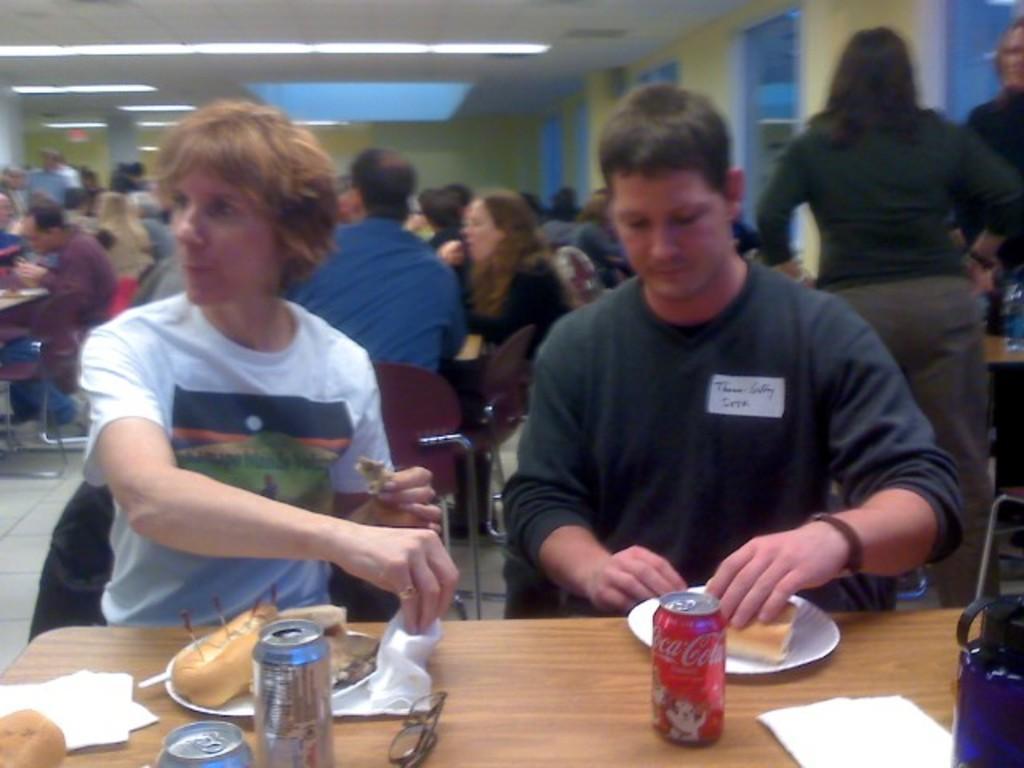In one or two sentences, can you explain what this image depicts? In the center of the image we can see person sitting at the table. On the table we can see beverages, bread, plates and tissues. In the background we can see many persons, light and wall. 